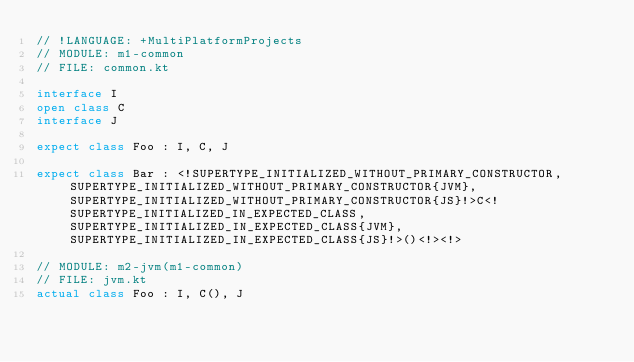<code> <loc_0><loc_0><loc_500><loc_500><_Kotlin_>// !LANGUAGE: +MultiPlatformProjects
// MODULE: m1-common
// FILE: common.kt

interface I
open class C
interface J

expect class Foo : I, C, J

expect class Bar : <!SUPERTYPE_INITIALIZED_WITHOUT_PRIMARY_CONSTRUCTOR, SUPERTYPE_INITIALIZED_WITHOUT_PRIMARY_CONSTRUCTOR{JVM}, SUPERTYPE_INITIALIZED_WITHOUT_PRIMARY_CONSTRUCTOR{JS}!>C<!SUPERTYPE_INITIALIZED_IN_EXPECTED_CLASS, SUPERTYPE_INITIALIZED_IN_EXPECTED_CLASS{JVM}, SUPERTYPE_INITIALIZED_IN_EXPECTED_CLASS{JS}!>()<!><!>

// MODULE: m2-jvm(m1-common)
// FILE: jvm.kt
actual class Foo : I, C(), J
</code> 